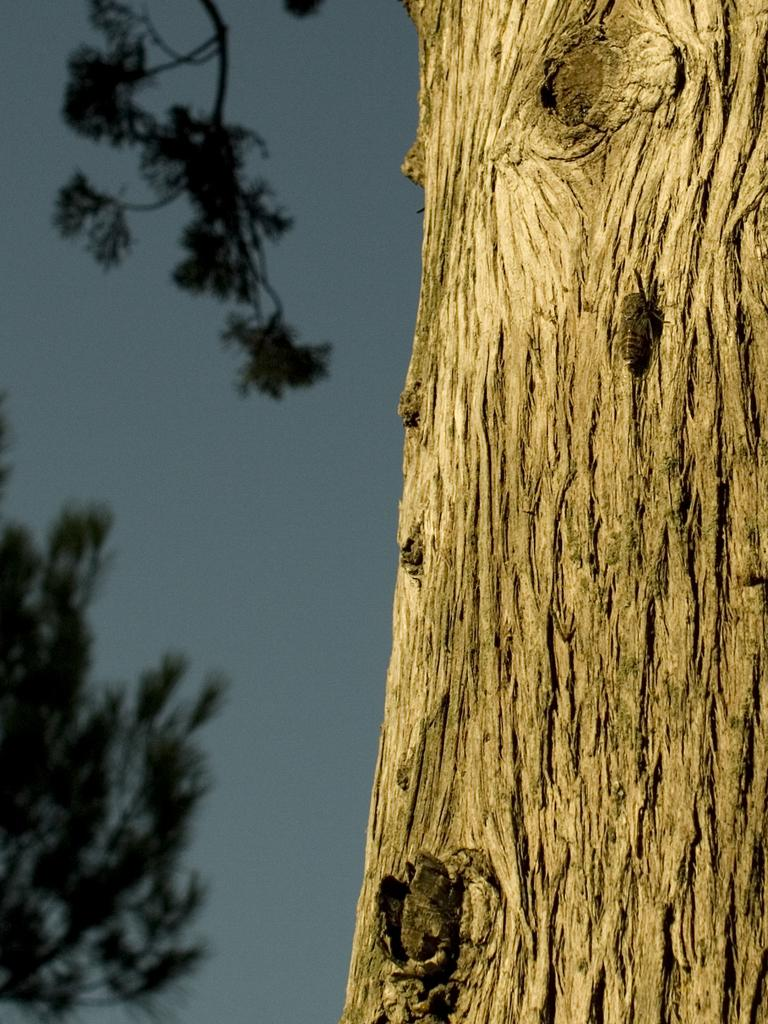What is the main subject of the image? The main subject of the image is a tree trunk. What can be seen on the left side of the tree trunk? There are branches with leaves on the left side of the tree trunk. What is visible in the background of the image? The sky is visible in the background of the image. What type of detail can be seen on the loaf of bread in the image? There is no loaf of bread present in the image; it is a tree trunk with branches and leaves. How many clouds are visible in the image? The provided facts do not mention any clouds in the image; only the sky is mentioned as being visible in the background. 